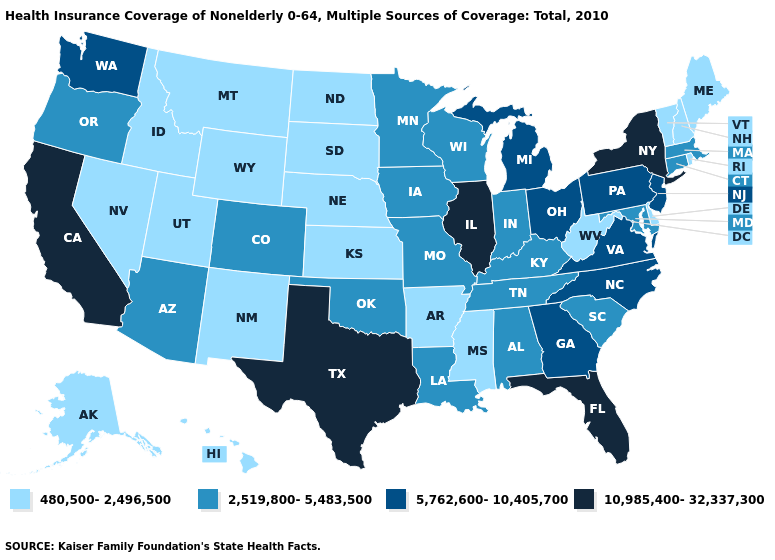Name the states that have a value in the range 2,519,800-5,483,500?
Be succinct. Alabama, Arizona, Colorado, Connecticut, Indiana, Iowa, Kentucky, Louisiana, Maryland, Massachusetts, Minnesota, Missouri, Oklahoma, Oregon, South Carolina, Tennessee, Wisconsin. Does the first symbol in the legend represent the smallest category?
Keep it brief. Yes. What is the highest value in states that border Indiana?
Keep it brief. 10,985,400-32,337,300. What is the highest value in the USA?
Give a very brief answer. 10,985,400-32,337,300. Name the states that have a value in the range 5,762,600-10,405,700?
Write a very short answer. Georgia, Michigan, New Jersey, North Carolina, Ohio, Pennsylvania, Virginia, Washington. What is the highest value in the Northeast ?
Concise answer only. 10,985,400-32,337,300. What is the lowest value in states that border Missouri?
Give a very brief answer. 480,500-2,496,500. Among the states that border Ohio , which have the lowest value?
Write a very short answer. West Virginia. What is the value of New Jersey?
Keep it brief. 5,762,600-10,405,700. What is the value of Alabama?
Quick response, please. 2,519,800-5,483,500. What is the highest value in states that border Arkansas?
Short answer required. 10,985,400-32,337,300. Does Illinois have the highest value in the USA?
Give a very brief answer. Yes. Among the states that border Maryland , which have the lowest value?
Keep it brief. Delaware, West Virginia. What is the value of Maine?
Quick response, please. 480,500-2,496,500. 